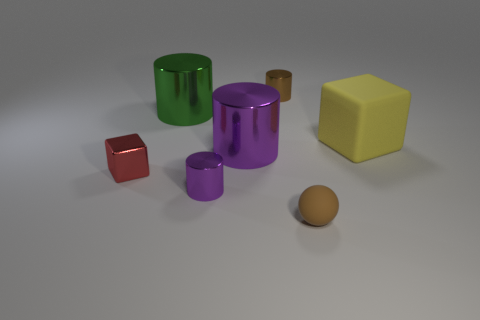There is a cylinder in front of the tiny red shiny thing; is there a big green metallic cylinder in front of it?
Keep it short and to the point. No. Is there any other thing that has the same shape as the red object?
Offer a terse response. Yes. Do the brown sphere and the brown metallic cylinder have the same size?
Your answer should be very brief. Yes. What is the material of the small brown thing that is to the right of the tiny brown thing that is left of the brown thing in front of the brown cylinder?
Provide a short and direct response. Rubber. Is the number of small purple objects that are right of the large yellow thing the same as the number of large brown metal spheres?
Offer a terse response. Yes. Is there anything else that is the same size as the green thing?
Offer a terse response. Yes. How many objects are either small red things or small purple metallic things?
Make the answer very short. 2. What shape is the tiny purple object that is the same material as the red object?
Give a very brief answer. Cylinder. There is a green metal object that is behind the large thing that is right of the tiny brown shiny cylinder; what size is it?
Make the answer very short. Large. How many large things are spheres or purple matte cubes?
Give a very brief answer. 0. 